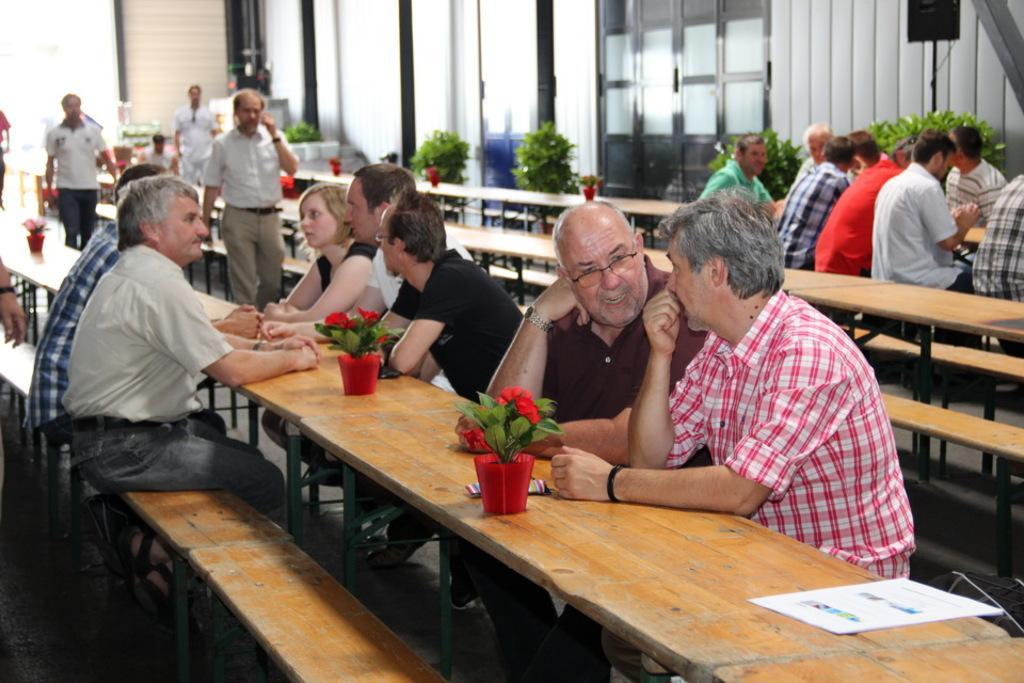How would you summarize this image in a sentence or two? In this picture there are group of people, those who are sitting around the table and there are flower pots around the table, there is a glass door at the center of the image. 